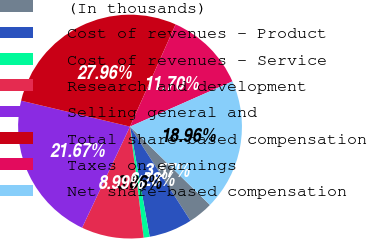Convert chart to OTSL. <chart><loc_0><loc_0><loc_500><loc_500><pie_chart><fcel>(In thousands)<fcel>Cost of revenues - Product<fcel>Cost of revenues - Service<fcel>Research and development<fcel>Selling general and<fcel>Total share-based compensation<fcel>Taxes on earnings<fcel>Net share-based compensation<nl><fcel>3.57%<fcel>6.28%<fcel>0.86%<fcel>8.99%<fcel>21.67%<fcel>27.96%<fcel>11.7%<fcel>18.96%<nl></chart> 